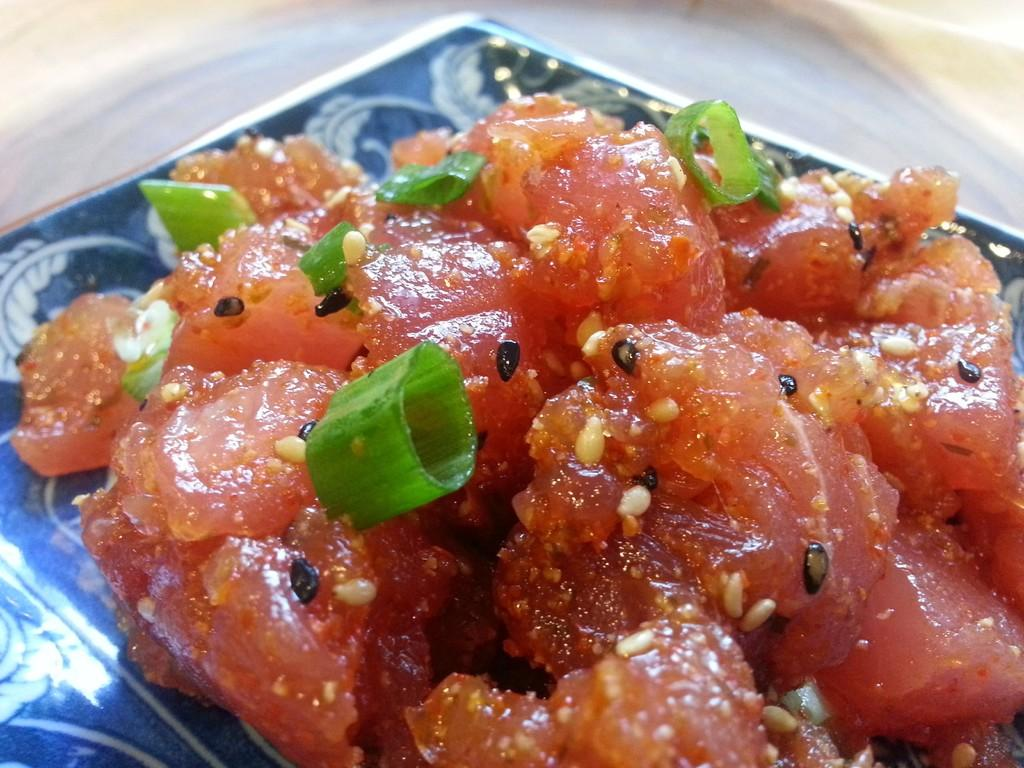What object is present in the image that is typically used for serving food? There is a plate in the image. What can be found on top of the plate? There is a food item on top of the plate. How many religious artifacts are present in the image? There is no information about religious artifacts in the image, as it only features a plate with a food item on top. 